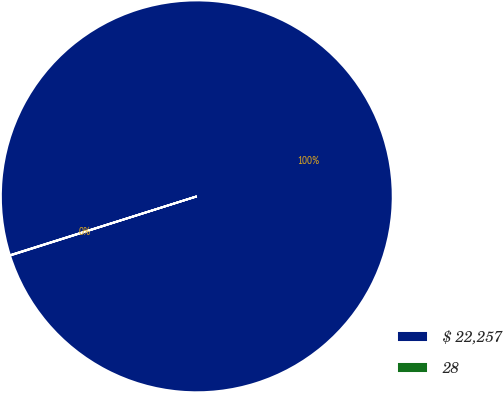Convert chart to OTSL. <chart><loc_0><loc_0><loc_500><loc_500><pie_chart><fcel>$ 22,257<fcel>28<nl><fcel>99.97%<fcel>0.03%<nl></chart> 